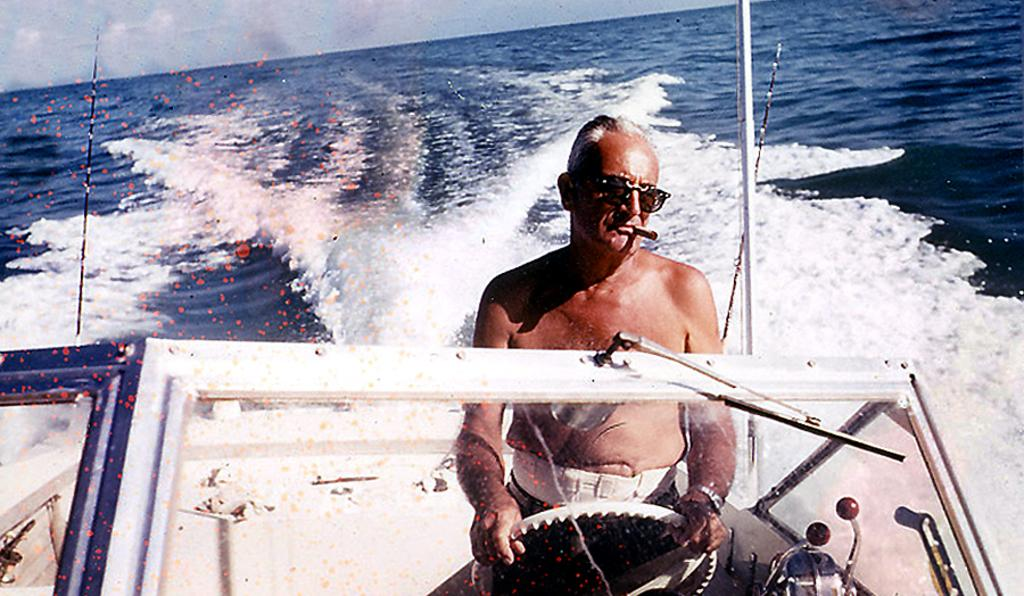What is the person in the image doing? The person is sitting on a boat in the image. What is the boat floating on? There is water visible in the image. What can be seen in the background of the image? The sky is visible in the background of the image. What type of crime is being committed in the image? There is no crime being committed in the image; it simply shows a person sitting on a boat. What kind of loaf is being used as a prop in the image? There is no loaf present in the image. 